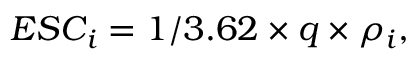<formula> <loc_0><loc_0><loc_500><loc_500>E S C _ { i } = 1 / 3 . 6 2 \times q \times \rho _ { i } ,</formula> 